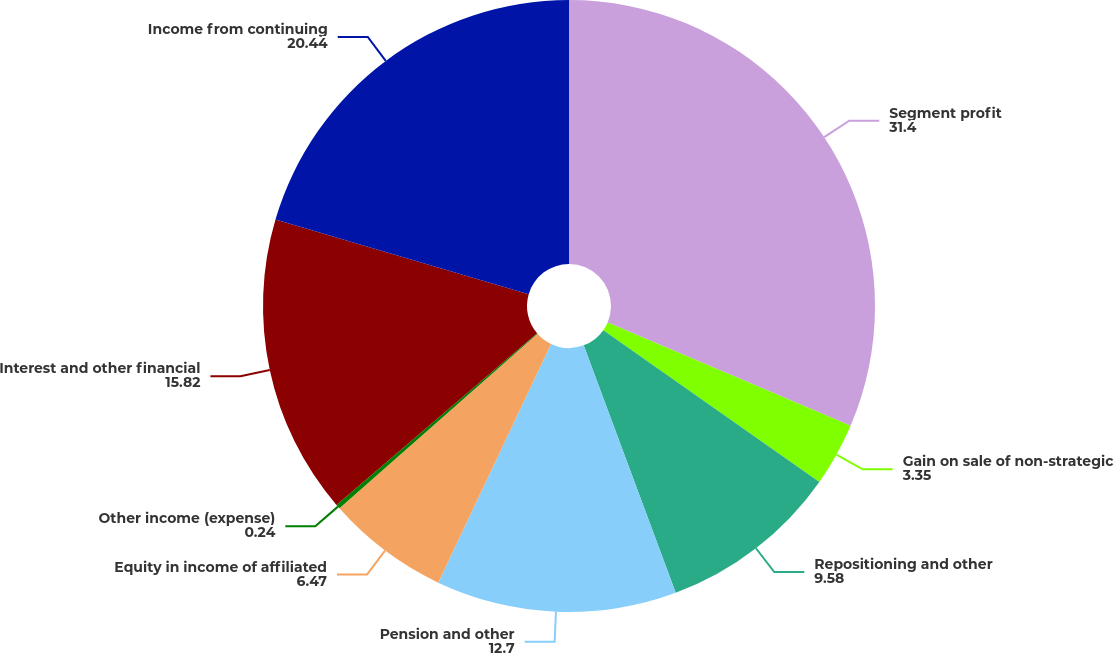Convert chart. <chart><loc_0><loc_0><loc_500><loc_500><pie_chart><fcel>Segment profit<fcel>Gain on sale of non-strategic<fcel>Repositioning and other<fcel>Pension and other<fcel>Equity in income of affiliated<fcel>Other income (expense)<fcel>Interest and other financial<fcel>Income from continuing<nl><fcel>31.4%<fcel>3.35%<fcel>9.58%<fcel>12.7%<fcel>6.47%<fcel>0.24%<fcel>15.82%<fcel>20.44%<nl></chart> 